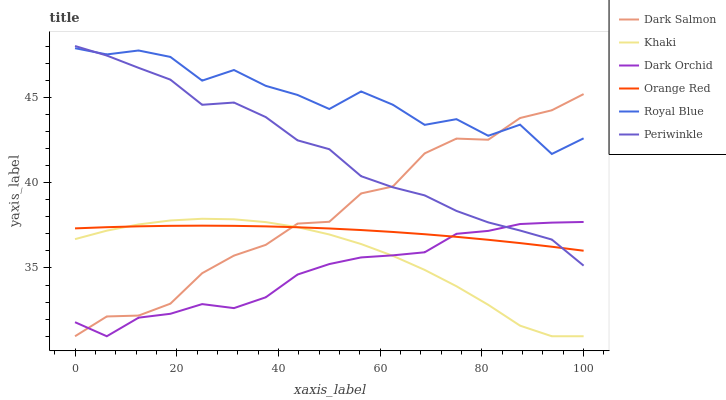Does Dark Orchid have the minimum area under the curve?
Answer yes or no. Yes. Does Royal Blue have the maximum area under the curve?
Answer yes or no. Yes. Does Dark Salmon have the minimum area under the curve?
Answer yes or no. No. Does Dark Salmon have the maximum area under the curve?
Answer yes or no. No. Is Orange Red the smoothest?
Answer yes or no. Yes. Is Royal Blue the roughest?
Answer yes or no. Yes. Is Dark Salmon the smoothest?
Answer yes or no. No. Is Dark Salmon the roughest?
Answer yes or no. No. Does Khaki have the lowest value?
Answer yes or no. Yes. Does Royal Blue have the lowest value?
Answer yes or no. No. Does Periwinkle have the highest value?
Answer yes or no. Yes. Does Dark Salmon have the highest value?
Answer yes or no. No. Is Khaki less than Periwinkle?
Answer yes or no. Yes. Is Royal Blue greater than Orange Red?
Answer yes or no. Yes. Does Dark Salmon intersect Royal Blue?
Answer yes or no. Yes. Is Dark Salmon less than Royal Blue?
Answer yes or no. No. Is Dark Salmon greater than Royal Blue?
Answer yes or no. No. Does Khaki intersect Periwinkle?
Answer yes or no. No. 